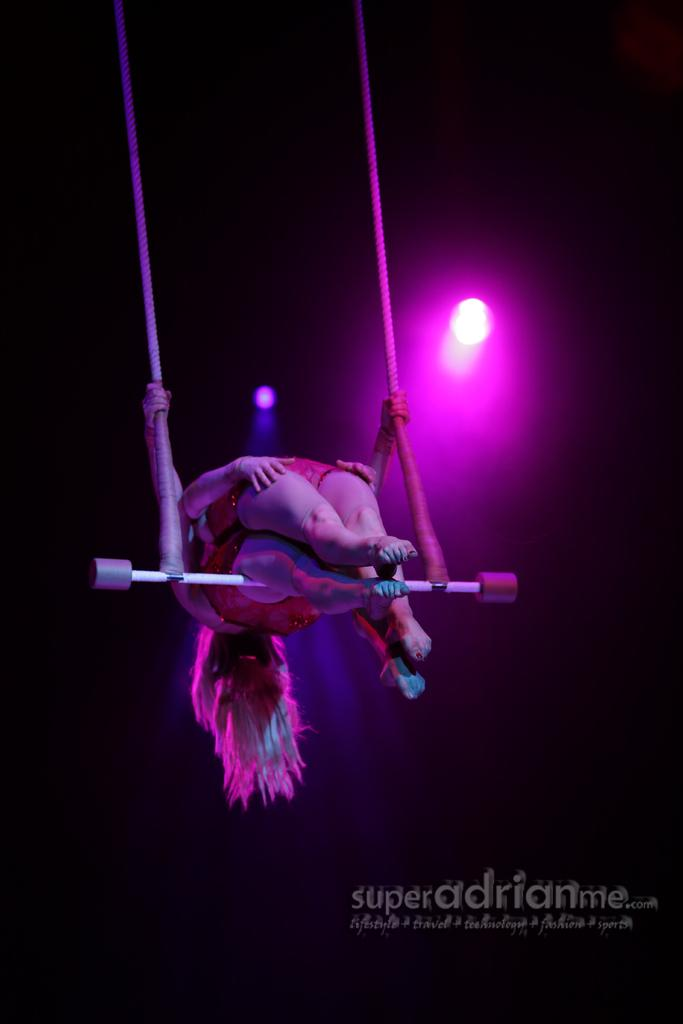What are the persons in the image doing? The persons in the image are performing acrobatics. What language is being spoken by the persons in the image? There is no information provided about the language being spoken in the image. Additionally, it is not possible to determine the language being spoken based solely on the visual content of the image. 